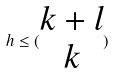<formula> <loc_0><loc_0><loc_500><loc_500>h \leq ( \begin{matrix} k + l \\ k \end{matrix} )</formula> 